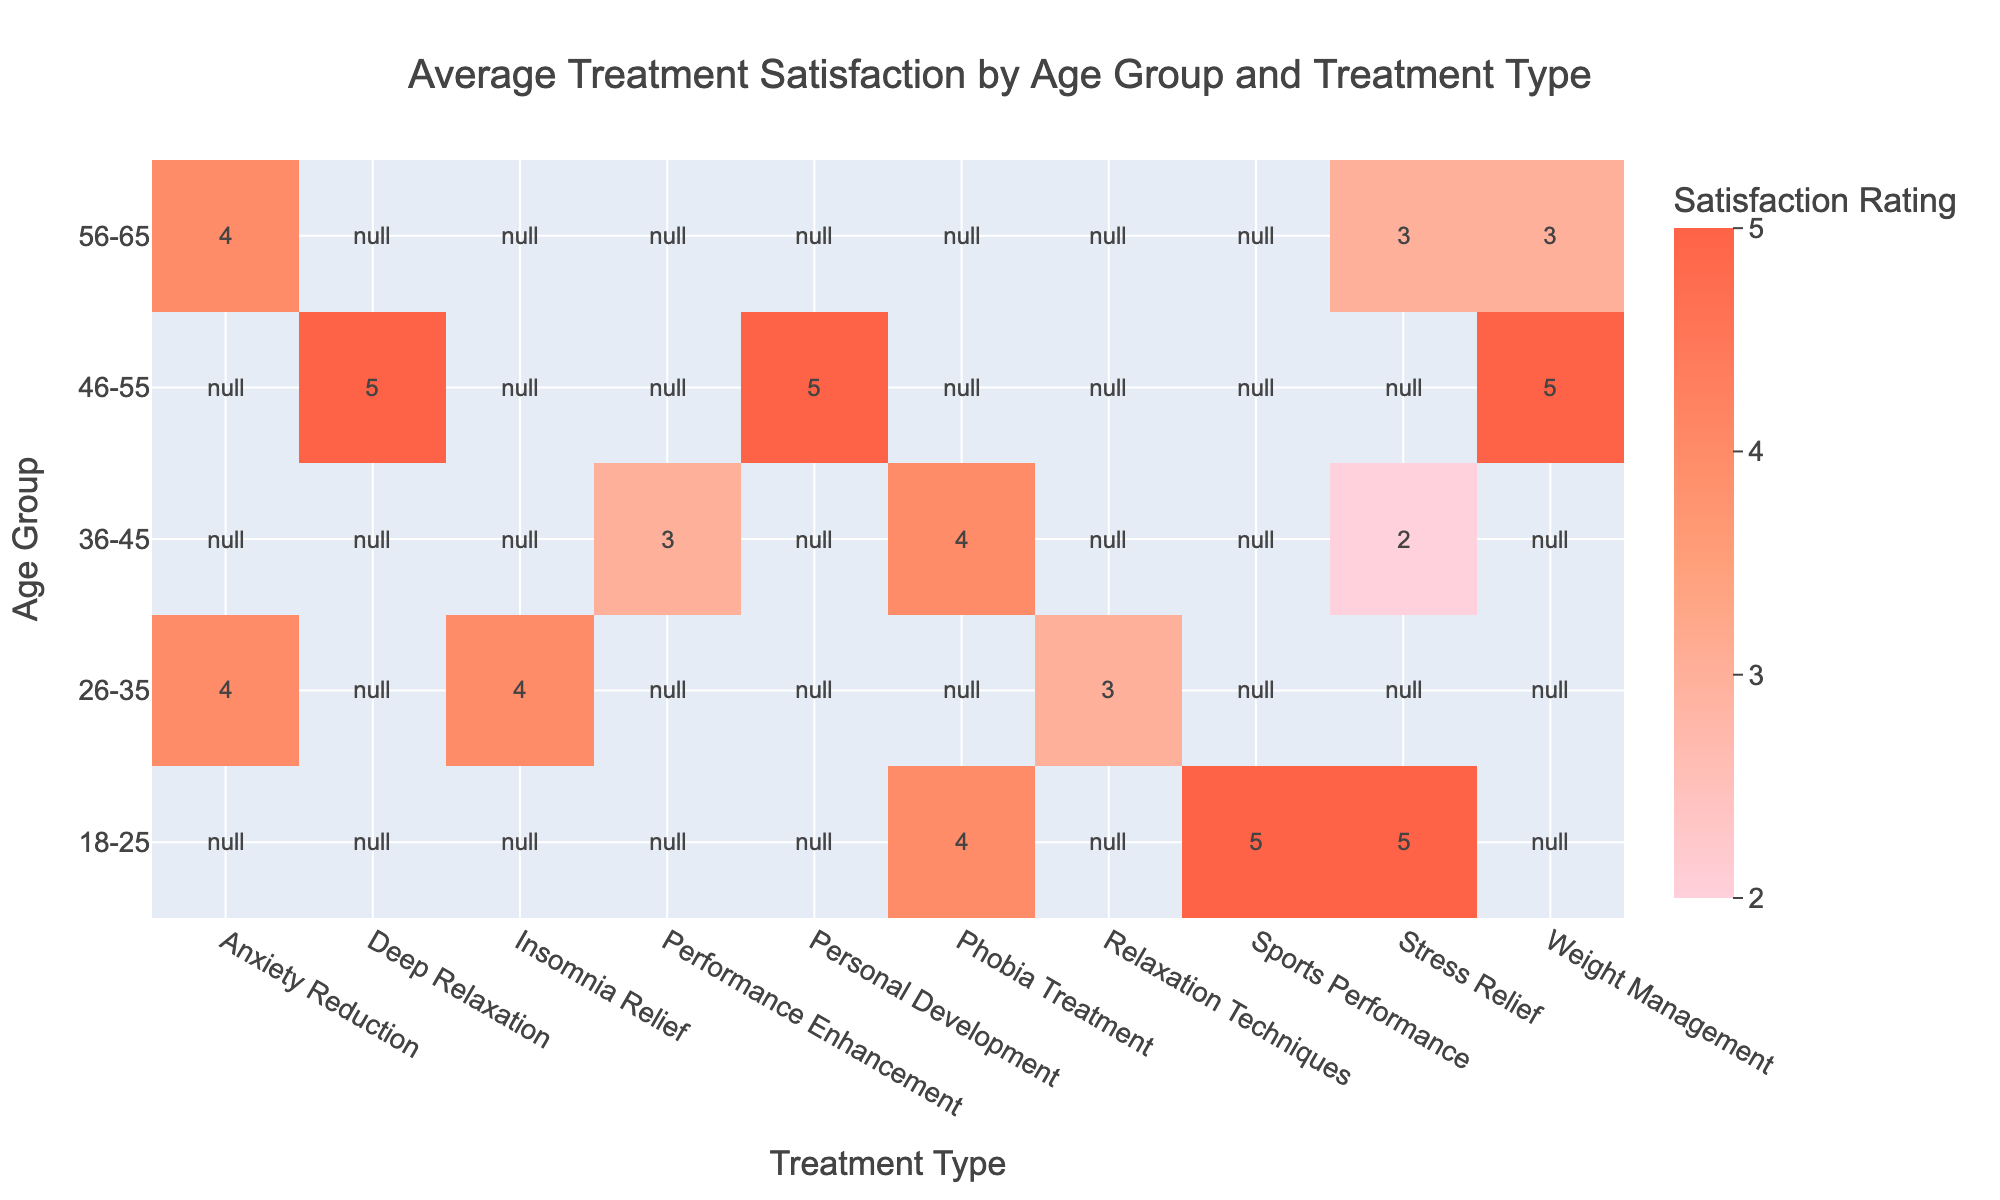What is the average treatment satisfaction rating for the 'Stress Relief' treatment among clients aged 18-25? For the 'Stress Relief' treatment in the 18-25 age group, there is one client (ID 1) with a satisfaction rating of 5. Therefore, the average is simply 5.
Answer: 5 How many different treatment types are offered to clients aged 36-45? Looking at the 36-45 age group, the treatment types listed are 'Performance Enhancement', 'Stress Relief', and 'Phobia Treatment'. This accounts for 3 distinct treatment types.
Answer: 3 Is the average treatment satisfaction rating for males higher than that for females? The average satisfaction for males is calculated as follows: (4 + 5 + 4 + 3) / 4 = 4. For females, the average is (5 + 3 + 4 + 5 + 3) / 5 = 4. The averages are equal; hence, the answer is no.
Answer: No What is the lowest treatment satisfaction rating reported in the table? Scanning through the ratings, the lowest value is 2, which is reported for 'Stress Relief' among clients aged 36-45 (ID 8).
Answer: 2 Which age group has the highest average treatment satisfaction rating? To find the highest average, we calculate the averages for all age groups: for 18-25 it's (5 + 4 + 5) / 3 = 4.67, for 26-35 it’s (4 + 3) / 2 = 3.5, for 36-45 it’s (3 + 2 + 4) / 3 = 3, for 46-55 it’s (5 + 5) / 2 = 5, and for 56-65 it's (3 + 4) / 2 = 3.5. The highest average is for the 46-55 age group at 5.
Answer: 46-55 What treatment type received the same rating from clients aged 46-55? Reviewing the 46-55 age group, both 'Deep Relaxation' and 'Weight Management' treatments have a rating of 5, indicating they received the same satisfaction rating.
Answer: Deep Relaxation and Weight Management 